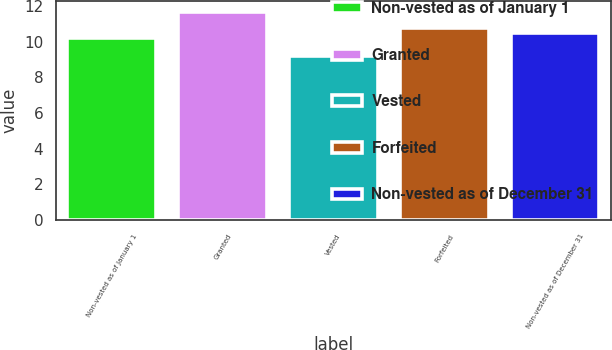<chart> <loc_0><loc_0><loc_500><loc_500><bar_chart><fcel>Non-vested as of January 1<fcel>Granted<fcel>Vested<fcel>Forfeited<fcel>Non-vested as of December 31<nl><fcel>10.21<fcel>11.69<fcel>9.19<fcel>10.76<fcel>10.49<nl></chart> 